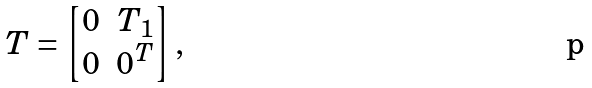Convert formula to latex. <formula><loc_0><loc_0><loc_500><loc_500>T = \begin{bmatrix} 0 & T _ { 1 } \\ 0 & 0 ^ { T } \end{bmatrix} ,</formula> 